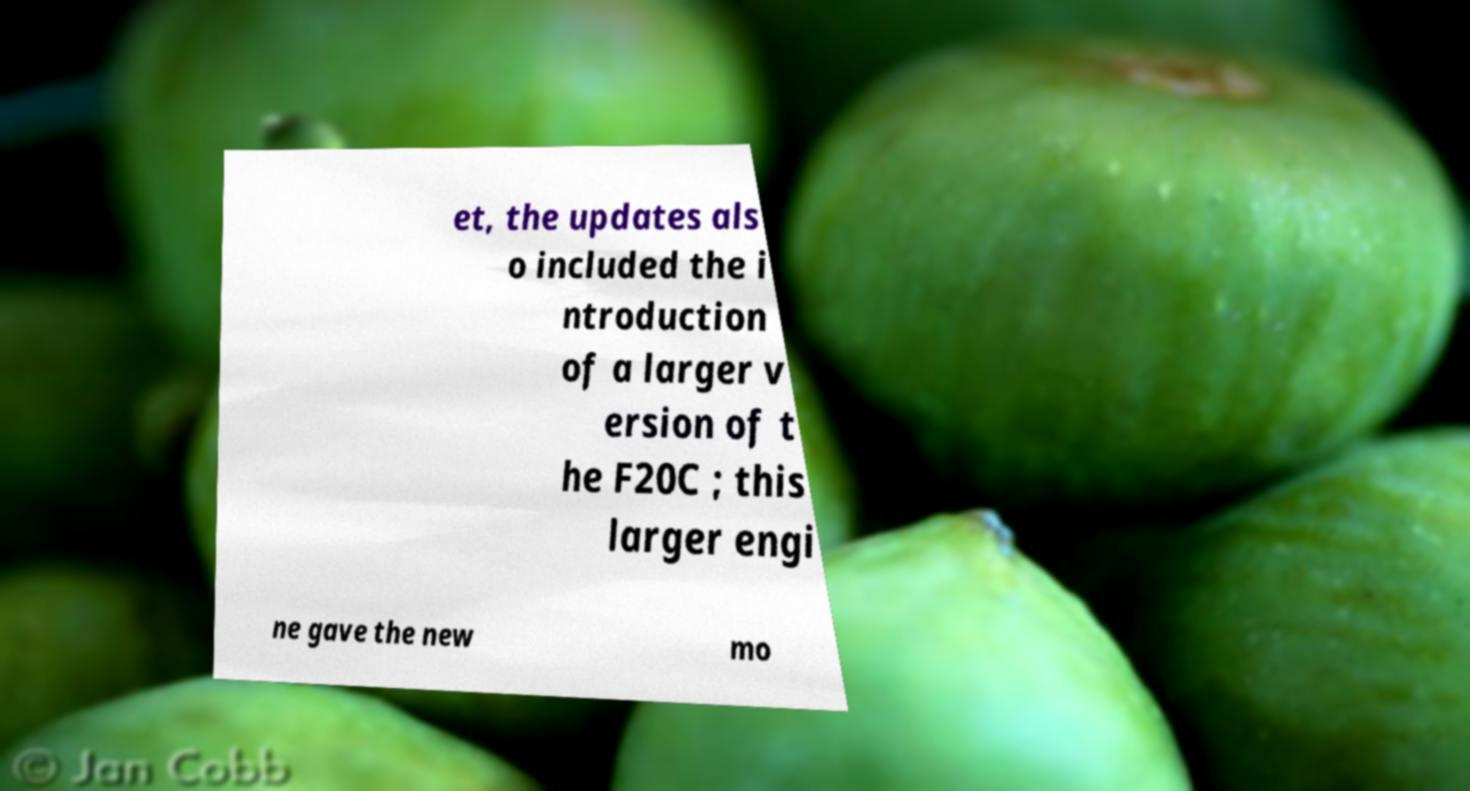Could you extract and type out the text from this image? et, the updates als o included the i ntroduction of a larger v ersion of t he F20C ; this larger engi ne gave the new mo 